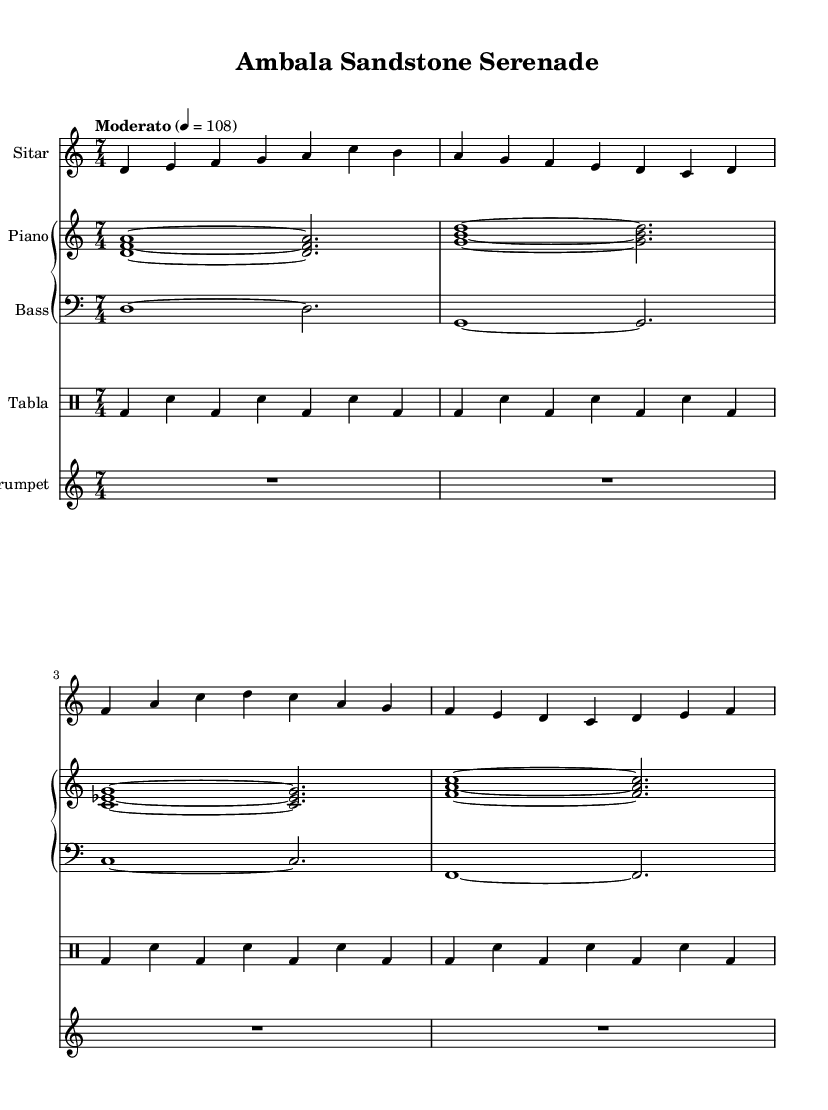What is the key signature of this music? The key signature is D Dorian, which is characterized by a minor quality with a raised sixth. This can be identified by looking at the key signature indicated in the global music settings.
Answer: D Dorian What is the time signature of this composition? The time signature displayed in the global section indicates a 7/4 time signature, which means there are seven beats in each measure and a quarter note gets one beat.
Answer: 7/4 What is the tempo marking of this piece? The tempo marking shows "Moderato" with a metronome marking of 108 beats per minute. This can be found under the global settings section.
Answer: Moderato, 108 Which instrument plays the melody primarily? The Sitar is set as the instrument that plays the primary melody throughout the composition, indicated by its notation in the sheet music.
Answer: Sitar How many measures does the Sitar part contain in total? By counting the measures indicated in the Sitar notation, there are a total of four measures in the provided music.
Answer: 4 What rhythmic pattern is used in the Tabla? The Tabla part features a consistent pattern of bass and snare strikes, specifically alternating between bass drum (bd) and snare (sn). This is evident in the notation displayed.
Answer: bd-sn What is the role of the Trumpet in this composition? The Trumpet in this piece is marked with rhythm rests for four measures, indicating that it does not play during this section of the music. Its role may be for occasional highlights or solo passages later.
Answer: R1*7/4 